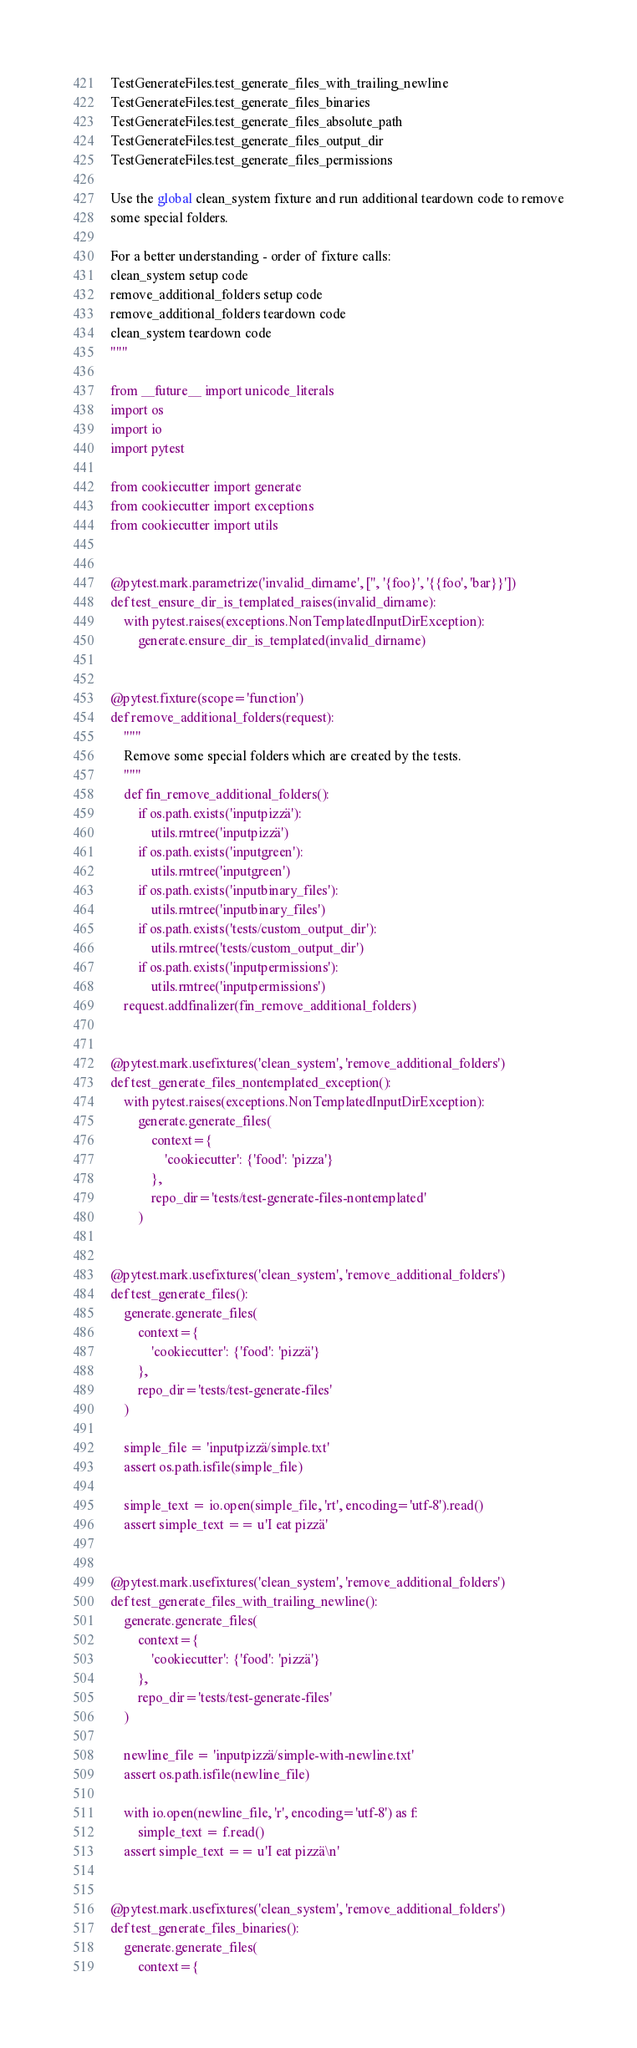Convert code to text. <code><loc_0><loc_0><loc_500><loc_500><_Python_>TestGenerateFiles.test_generate_files_with_trailing_newline
TestGenerateFiles.test_generate_files_binaries
TestGenerateFiles.test_generate_files_absolute_path
TestGenerateFiles.test_generate_files_output_dir
TestGenerateFiles.test_generate_files_permissions

Use the global clean_system fixture and run additional teardown code to remove
some special folders.

For a better understanding - order of fixture calls:
clean_system setup code
remove_additional_folders setup code
remove_additional_folders teardown code
clean_system teardown code
"""

from __future__ import unicode_literals
import os
import io
import pytest

from cookiecutter import generate
from cookiecutter import exceptions
from cookiecutter import utils


@pytest.mark.parametrize('invalid_dirname', ['', '{foo}', '{{foo', 'bar}}'])
def test_ensure_dir_is_templated_raises(invalid_dirname):
    with pytest.raises(exceptions.NonTemplatedInputDirException):
        generate.ensure_dir_is_templated(invalid_dirname)


@pytest.fixture(scope='function')
def remove_additional_folders(request):
    """
    Remove some special folders which are created by the tests.
    """
    def fin_remove_additional_folders():
        if os.path.exists('inputpizzä'):
            utils.rmtree('inputpizzä')
        if os.path.exists('inputgreen'):
            utils.rmtree('inputgreen')
        if os.path.exists('inputbinary_files'):
            utils.rmtree('inputbinary_files')
        if os.path.exists('tests/custom_output_dir'):
            utils.rmtree('tests/custom_output_dir')
        if os.path.exists('inputpermissions'):
            utils.rmtree('inputpermissions')
    request.addfinalizer(fin_remove_additional_folders)


@pytest.mark.usefixtures('clean_system', 'remove_additional_folders')
def test_generate_files_nontemplated_exception():
    with pytest.raises(exceptions.NonTemplatedInputDirException):
        generate.generate_files(
            context={
                'cookiecutter': {'food': 'pizza'}
            },
            repo_dir='tests/test-generate-files-nontemplated'
        )


@pytest.mark.usefixtures('clean_system', 'remove_additional_folders')
def test_generate_files():
    generate.generate_files(
        context={
            'cookiecutter': {'food': 'pizzä'}
        },
        repo_dir='tests/test-generate-files'
    )

    simple_file = 'inputpizzä/simple.txt'
    assert os.path.isfile(simple_file)

    simple_text = io.open(simple_file, 'rt', encoding='utf-8').read()
    assert simple_text == u'I eat pizzä'


@pytest.mark.usefixtures('clean_system', 'remove_additional_folders')
def test_generate_files_with_trailing_newline():
    generate.generate_files(
        context={
            'cookiecutter': {'food': 'pizzä'}
        },
        repo_dir='tests/test-generate-files'
    )

    newline_file = 'inputpizzä/simple-with-newline.txt'
    assert os.path.isfile(newline_file)

    with io.open(newline_file, 'r', encoding='utf-8') as f:
        simple_text = f.read()
    assert simple_text == u'I eat pizzä\n'


@pytest.mark.usefixtures('clean_system', 'remove_additional_folders')
def test_generate_files_binaries():
    generate.generate_files(
        context={</code> 